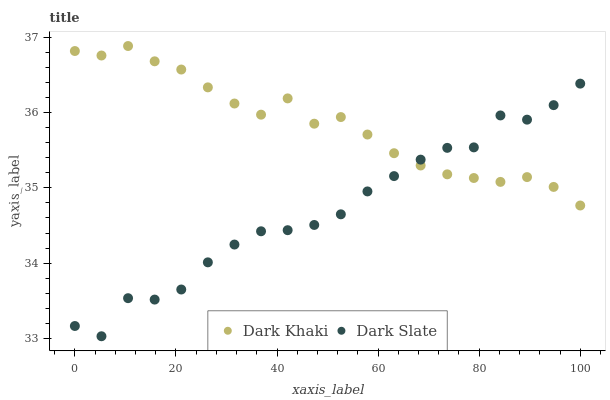Does Dark Slate have the minimum area under the curve?
Answer yes or no. Yes. Does Dark Khaki have the maximum area under the curve?
Answer yes or no. Yes. Does Dark Slate have the maximum area under the curve?
Answer yes or no. No. Is Dark Khaki the smoothest?
Answer yes or no. Yes. Is Dark Slate the roughest?
Answer yes or no. Yes. Is Dark Slate the smoothest?
Answer yes or no. No. Does Dark Slate have the lowest value?
Answer yes or no. Yes. Does Dark Khaki have the highest value?
Answer yes or no. Yes. Does Dark Slate have the highest value?
Answer yes or no. No. Does Dark Slate intersect Dark Khaki?
Answer yes or no. Yes. Is Dark Slate less than Dark Khaki?
Answer yes or no. No. Is Dark Slate greater than Dark Khaki?
Answer yes or no. No. 